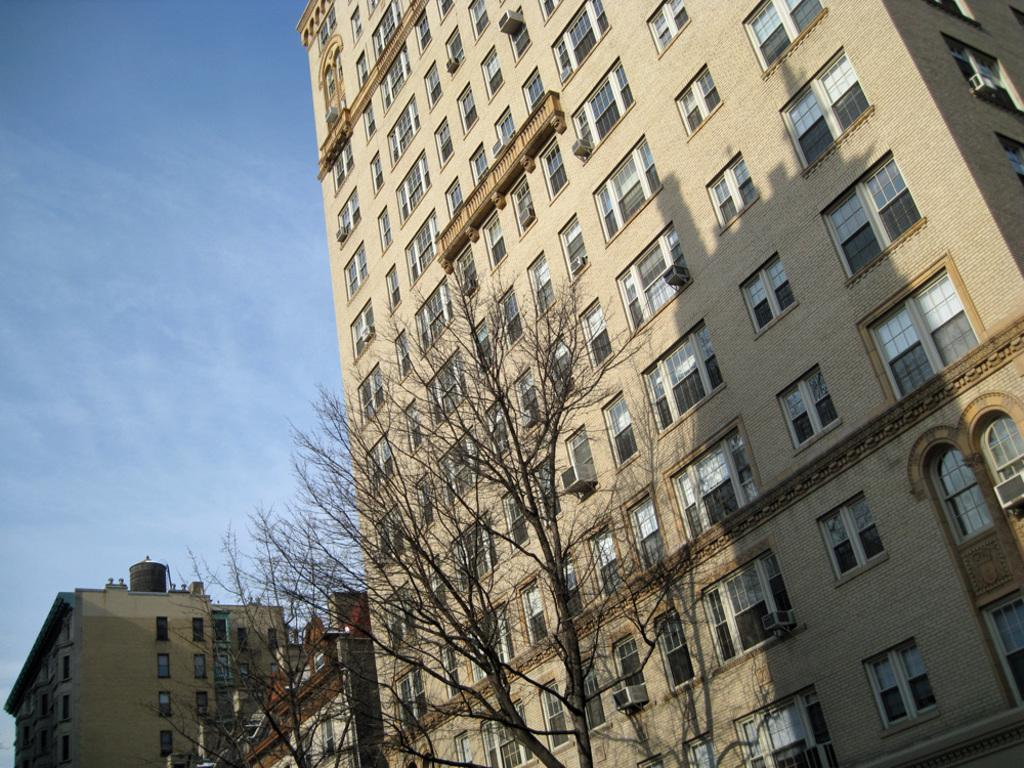What is located in the foreground of the image? There is a tree without leaves in the foreground of the image. What can be seen in the background of the image? There are buildings and the sky visible in the background of the image. What type of leather can be seen hanging from the tree in the image? There is no leather present in the image; it features a tree without leaves in the foreground. 